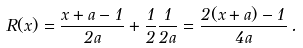<formula> <loc_0><loc_0><loc_500><loc_500>R ( x ) = \frac { x + a - 1 } { 2 a } + \frac { 1 } { 2 } \frac { 1 } { 2 a } = \frac { 2 ( x + a ) - 1 } { 4 a } \, .</formula> 